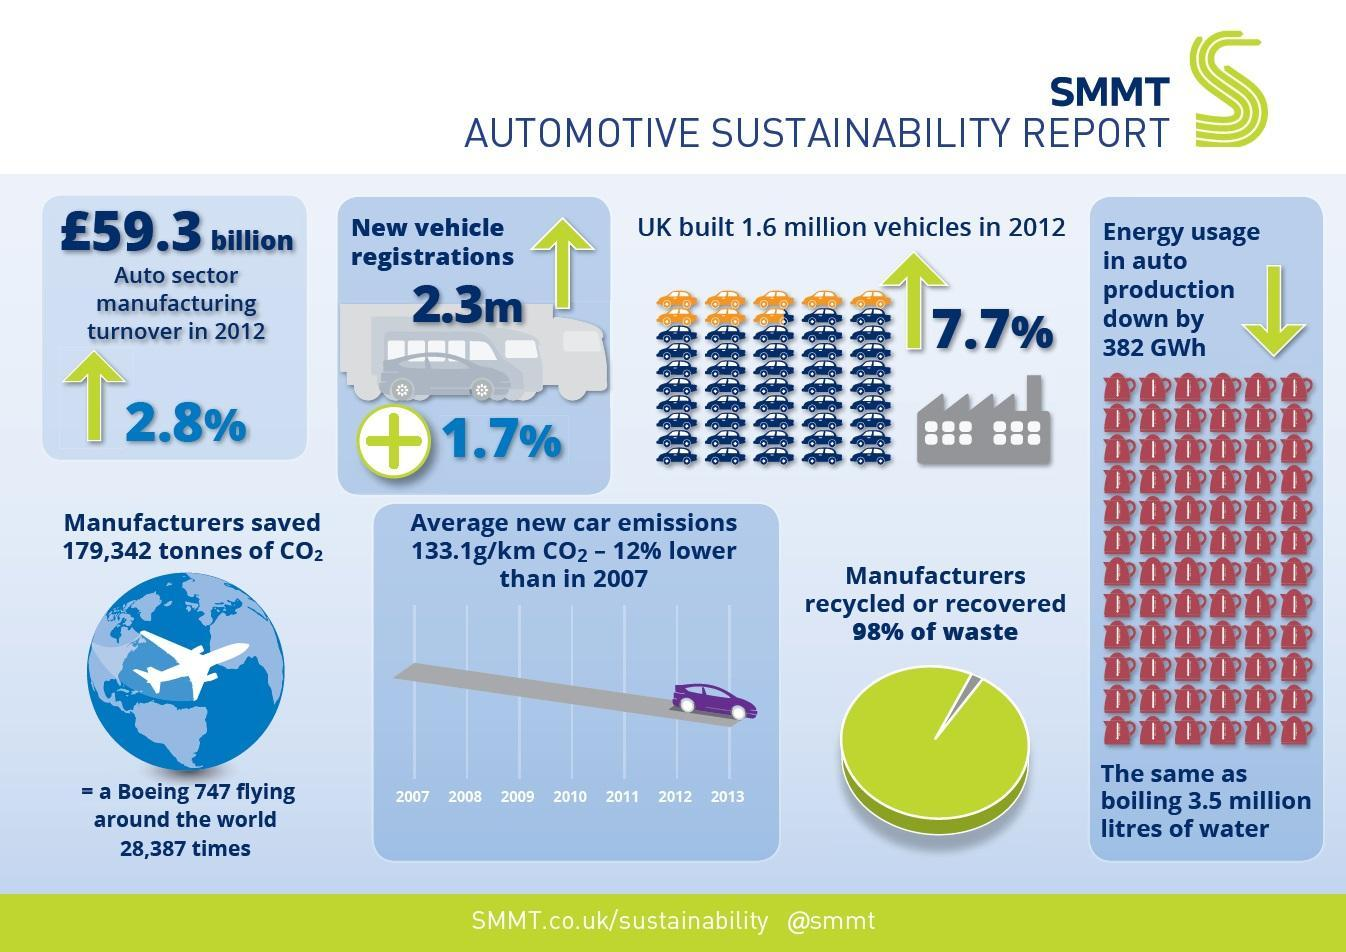What is the percentage increase registration of new vehicles, 7.7%, 2.8%, or 1.7%?
Answer the question with a short phrase. 1.7% Which year shows the lowest car emissions ? 2013 